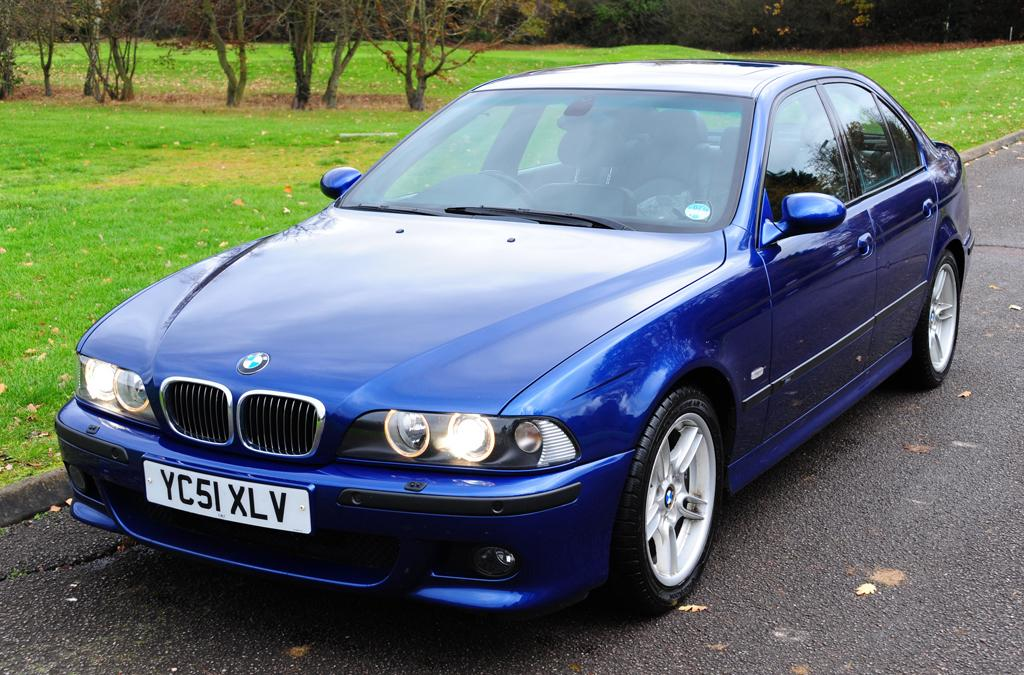What is the main subject of the image? There is a car on the road in the image. What can be seen on the ground in the image? Grass and leaves are visible on the ground in the image. What is visible in the background of the image? There are plants visible in the background of the image. What type of beetle can be seen driving the car in the image? There is no beetle present in the image, and the car is not being driven by any creature. What hobbies do the plants in the background of the image enjoy? Plants do not have hobbies, as they are not sentient beings. 